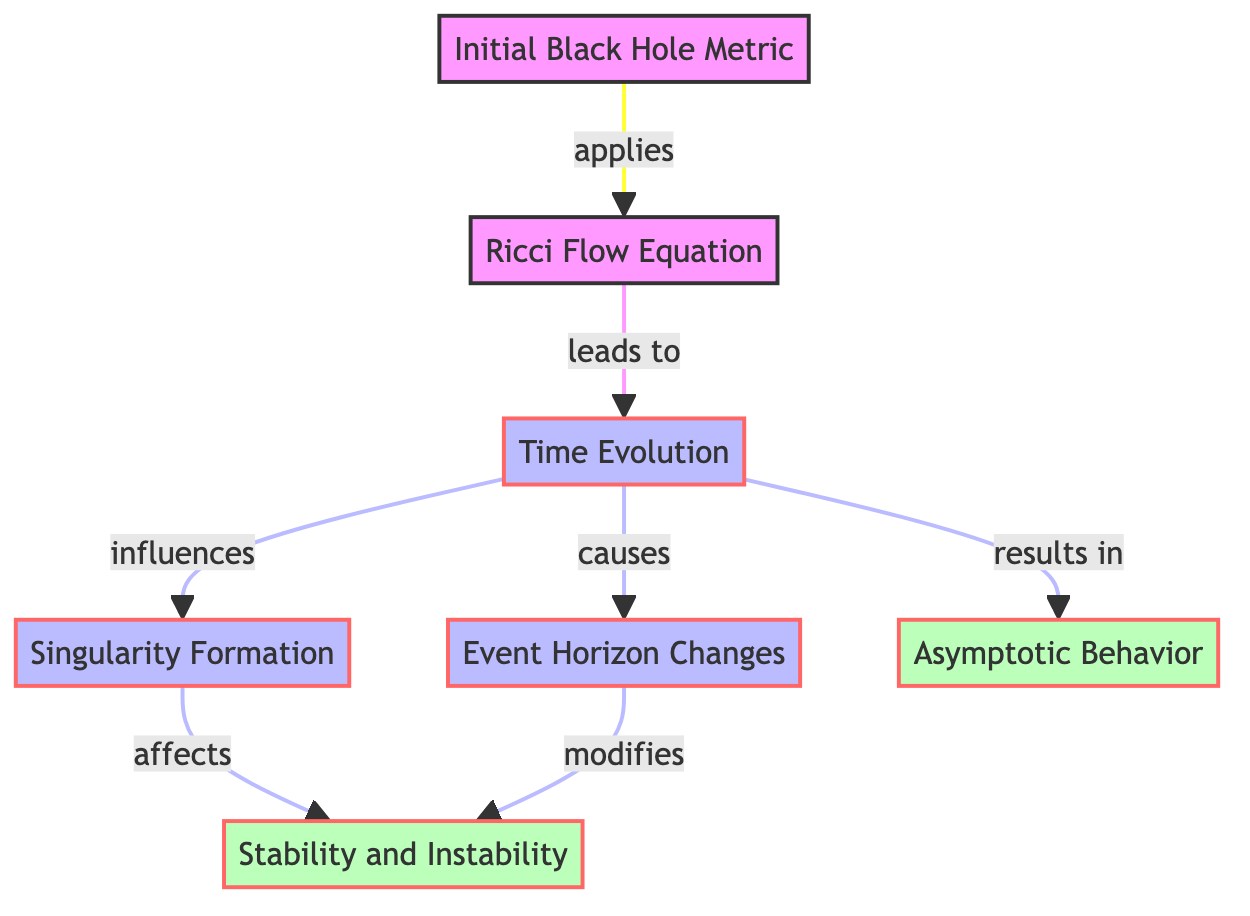What is the first node in the diagram? The first node clearly identified in the diagram is labeled "Initial Black Hole Metric," indicating it represents the starting point for the analysis.
Answer: Initial Black Hole Metric Which node follows the Ricci Flow Equation? The Ricci Flow Equation directly leads to the "Time Evolution" node, showcasing the sequential nature of the flow.
Answer: Time Evolution How many main nodes are labeled in the diagram? Counting each labeled node present in the diagram gives us a total of seven distinct main nodes.
Answer: Seven What is affected by the singularity formation? The "Stability and Instability" node is influenced by the "Singularity Formation," highlighting the interplay between these concepts in the flow.
Answer: Stability and Instability What effect does time evolution have on the event horizon changes? The "Time Evolution" directly causes changes in the "Event Horizon," indicating a direct causal relationship in the flow of dynamics.
Answer: Event Horizon Changes What node does the event horizon change modify? The "Event Horizon Changes" modifies the "Stability and Instability," showing that changes in one area can impact the stability of the black hole.
Answer: Stability and Instability What leads to the singularity formation node? The "Time Evolution" node influences the "Singularity Formation," highlighting the dependency of singularity on time evolution in the dynamic system.
Answer: Time Evolution Which node results from the time evolution process? The diagram specifies that the "Asymptotic Behavior" results from the "Time Evolution," indicating it is a consequence of the evolving conditions.
Answer: Asymptotic Behavior What is illustrated by the flow style in the diagram? The flow style indicates the active processes in the evolution over time, emphasizing components like time evolution, event horizon changes, and singularity formation.
Answer: Flow processes 